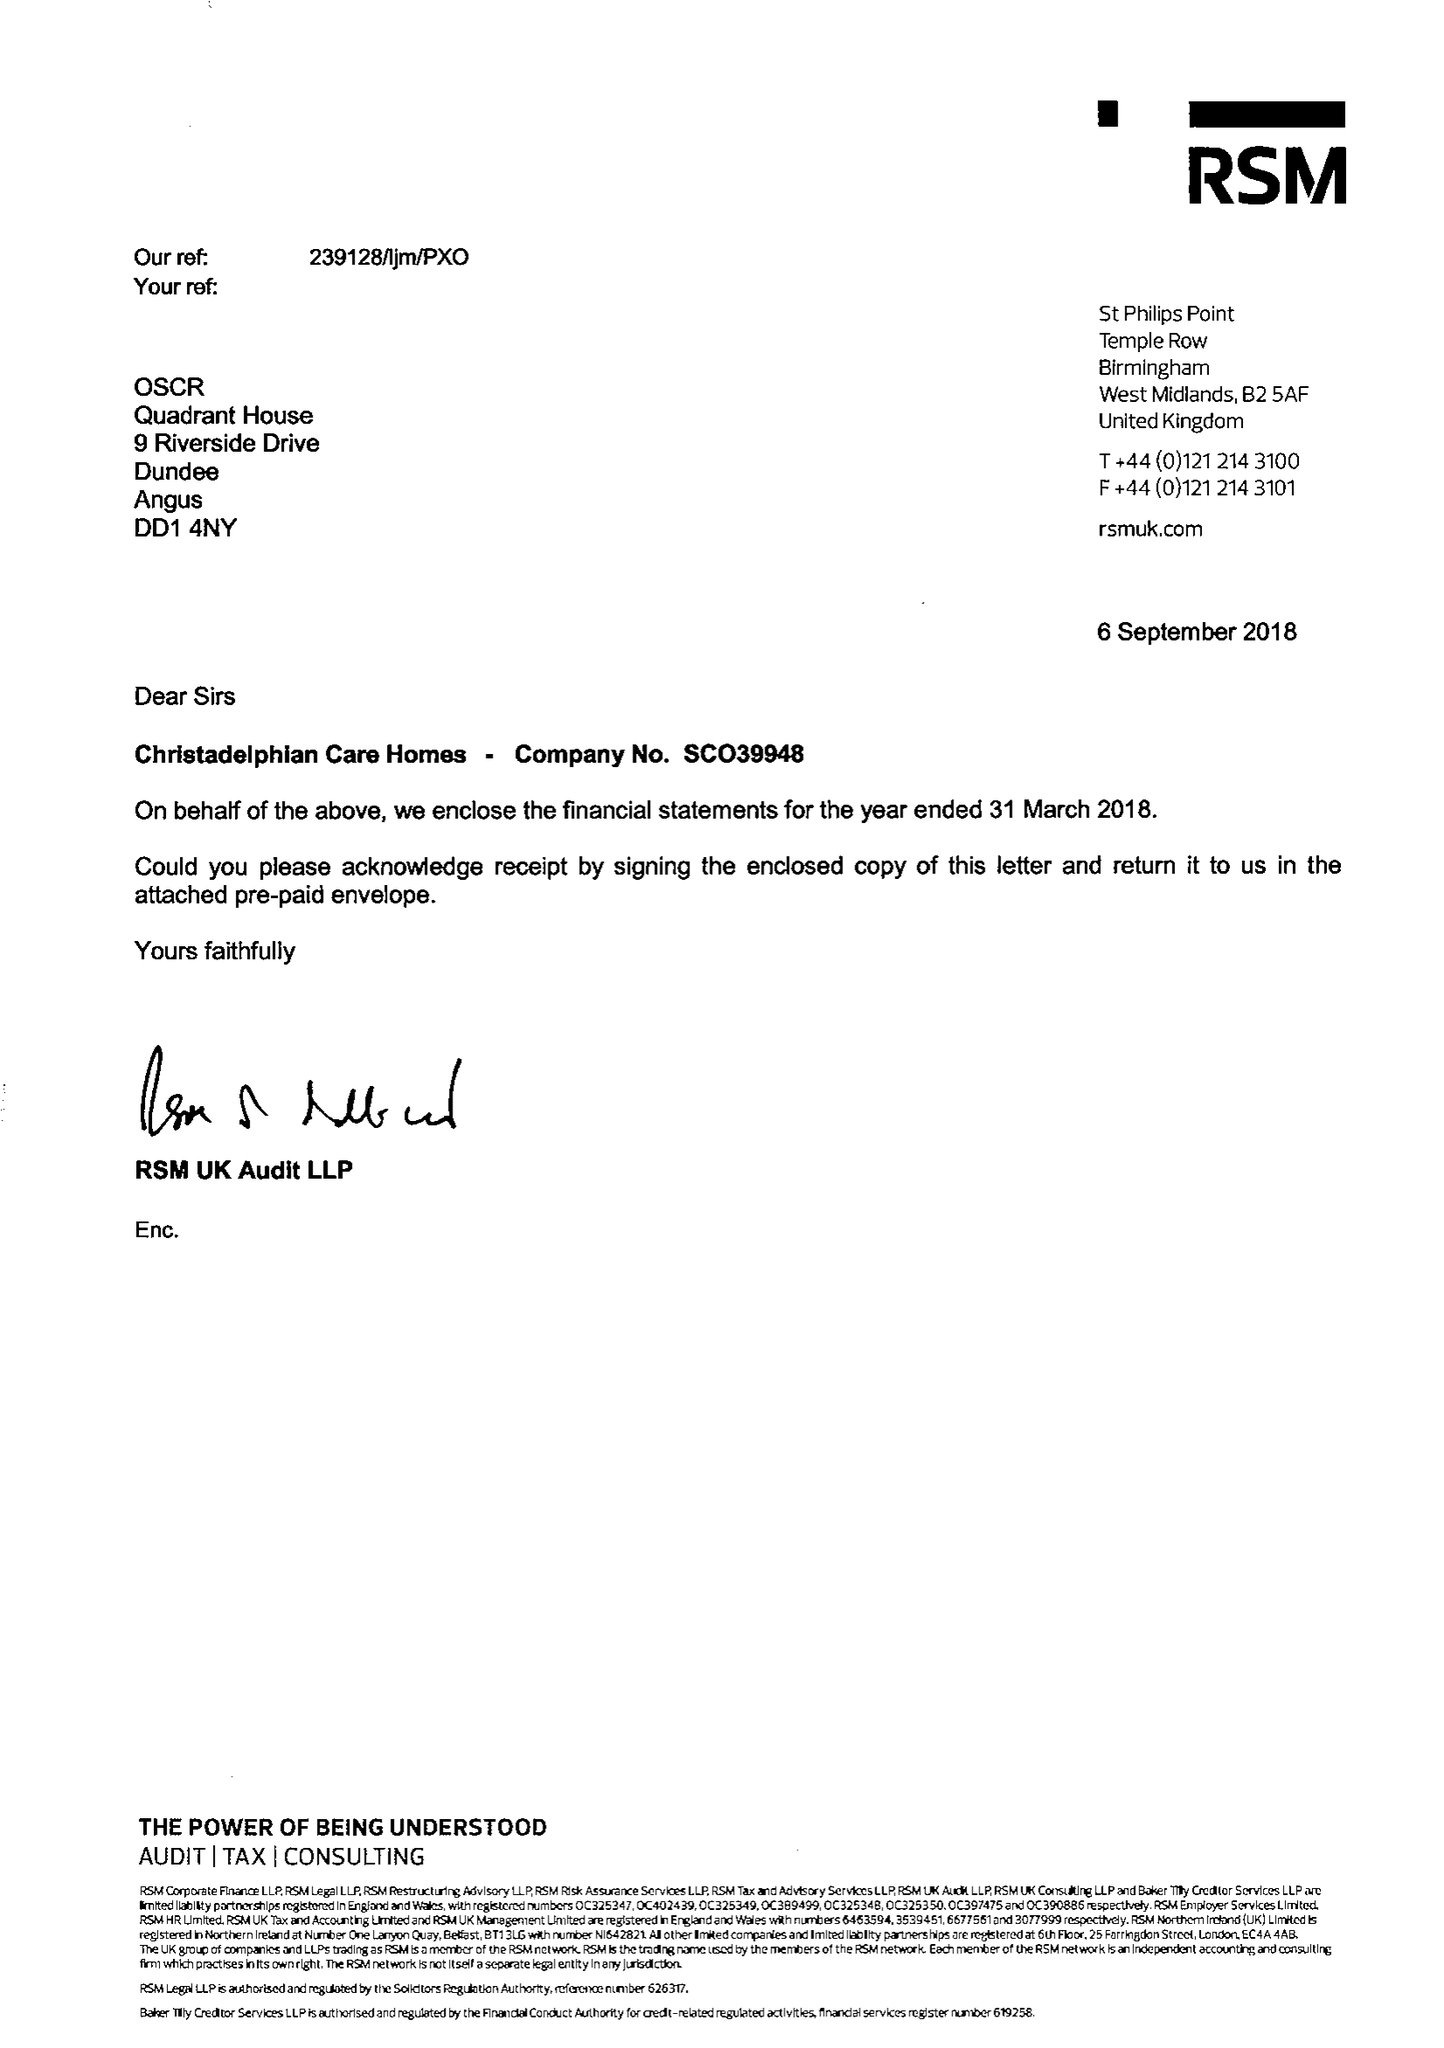What is the value for the address__post_town?
Answer the question using a single word or phrase. BIRMINGHAM 